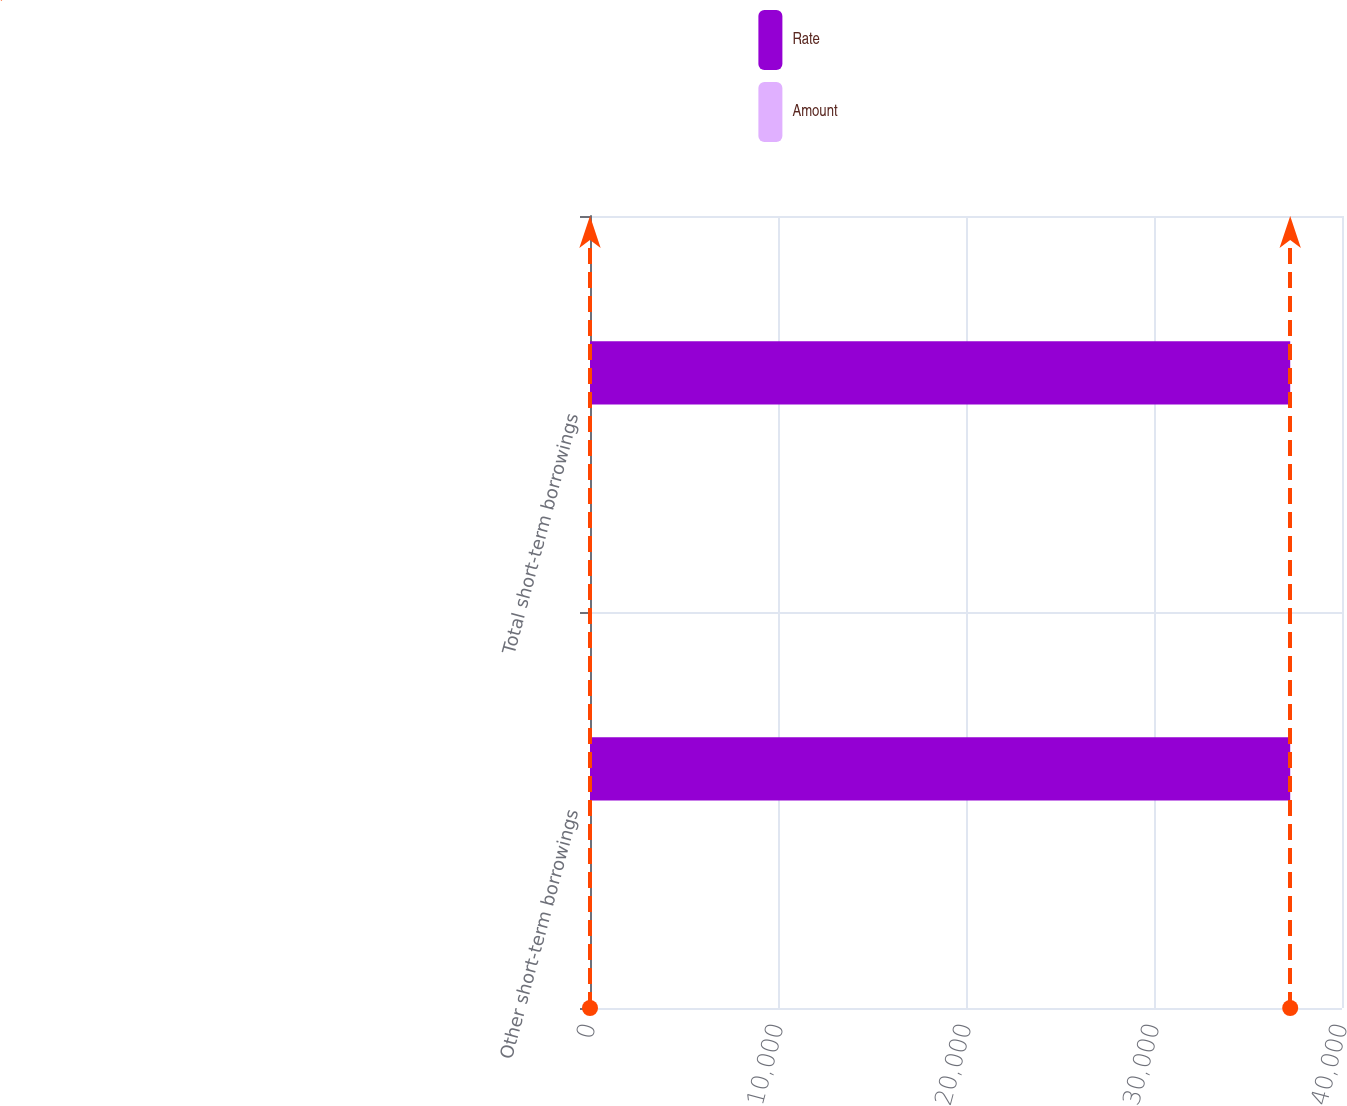<chart> <loc_0><loc_0><loc_500><loc_500><stacked_bar_chart><ecel><fcel>Other short-term borrowings<fcel>Total short-term borrowings<nl><fcel>Rate<fcel>37245<fcel>37245<nl><fcel>Amount<fcel>0.13<fcel>0.13<nl></chart> 